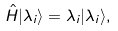<formula> <loc_0><loc_0><loc_500><loc_500>\hat { H } | \lambda _ { i } \rangle = \lambda _ { i } | \lambda _ { i } \rangle ,</formula> 